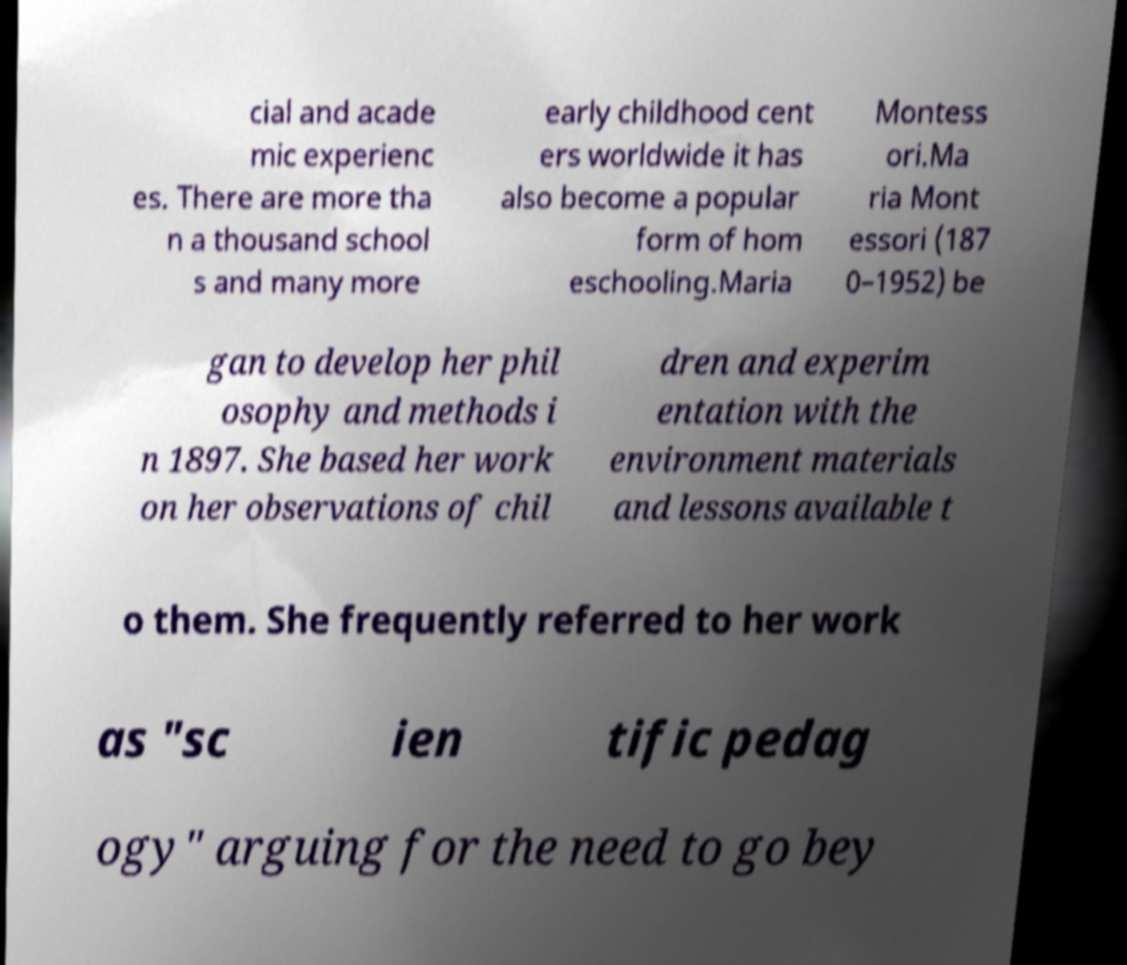Can you read and provide the text displayed in the image?This photo seems to have some interesting text. Can you extract and type it out for me? cial and acade mic experienc es. There are more tha n a thousand school s and many more early childhood cent ers worldwide it has also become a popular form of hom eschooling.Maria Montess ori.Ma ria Mont essori (187 0–1952) be gan to develop her phil osophy and methods i n 1897. She based her work on her observations of chil dren and experim entation with the environment materials and lessons available t o them. She frequently referred to her work as "sc ien tific pedag ogy" arguing for the need to go bey 